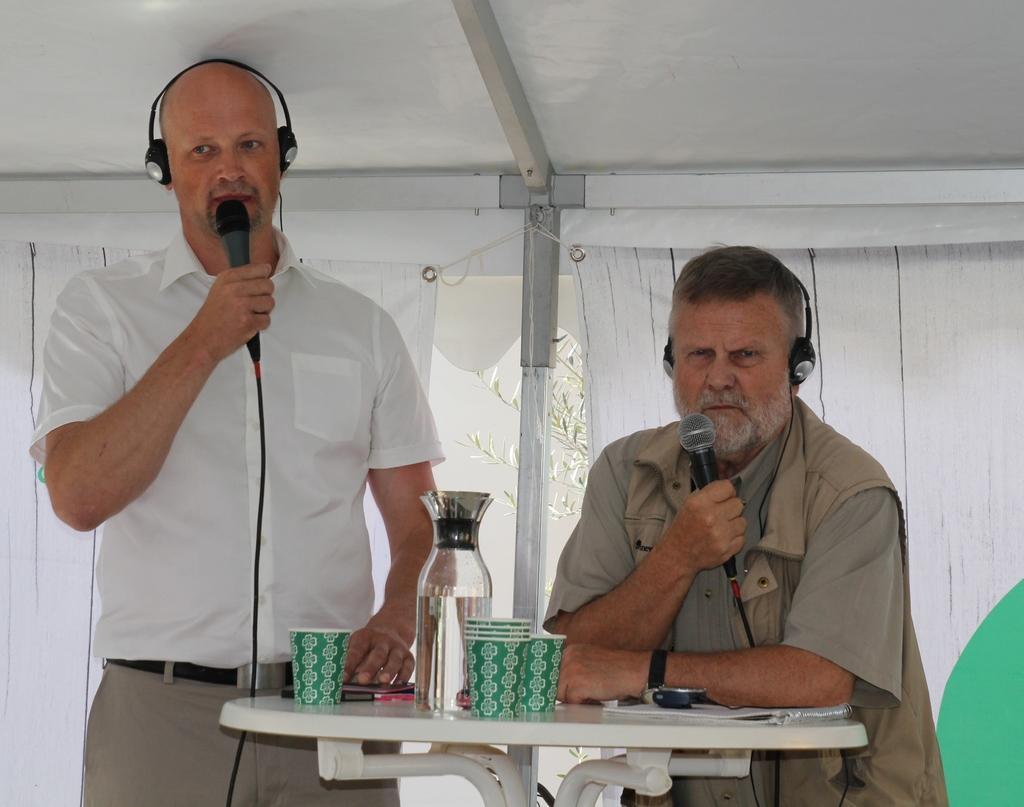Can you describe this image briefly? In this picture there are two men those who are standing at the center of the image and there is a table in front of them, on which there is a bottle and glasses, they both are holding the mics in their hands and wearing the headphones, and there is a white color background around the area of the image. 